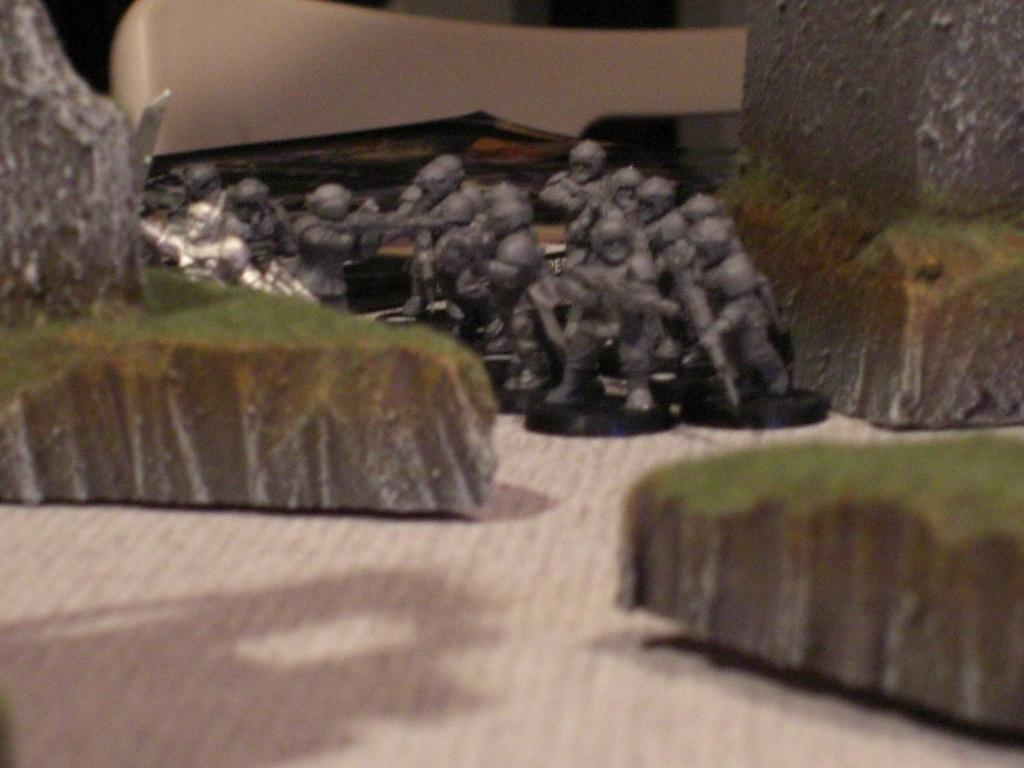What types of objects can be seen in the image? There are toys and rocks in the image. Can you describe the unspecified object in the image? Unfortunately, the fact only mentions that there is an unspecified object in the image, so we cannot provide more details about it. What is visible at the bottom of the image? The surface is visible at the bottom of the image. What type of prose is the dad reading to the children in the image? There is no dad, children, or prose present in the image; it only features toys, rocks, and an unspecified object. 